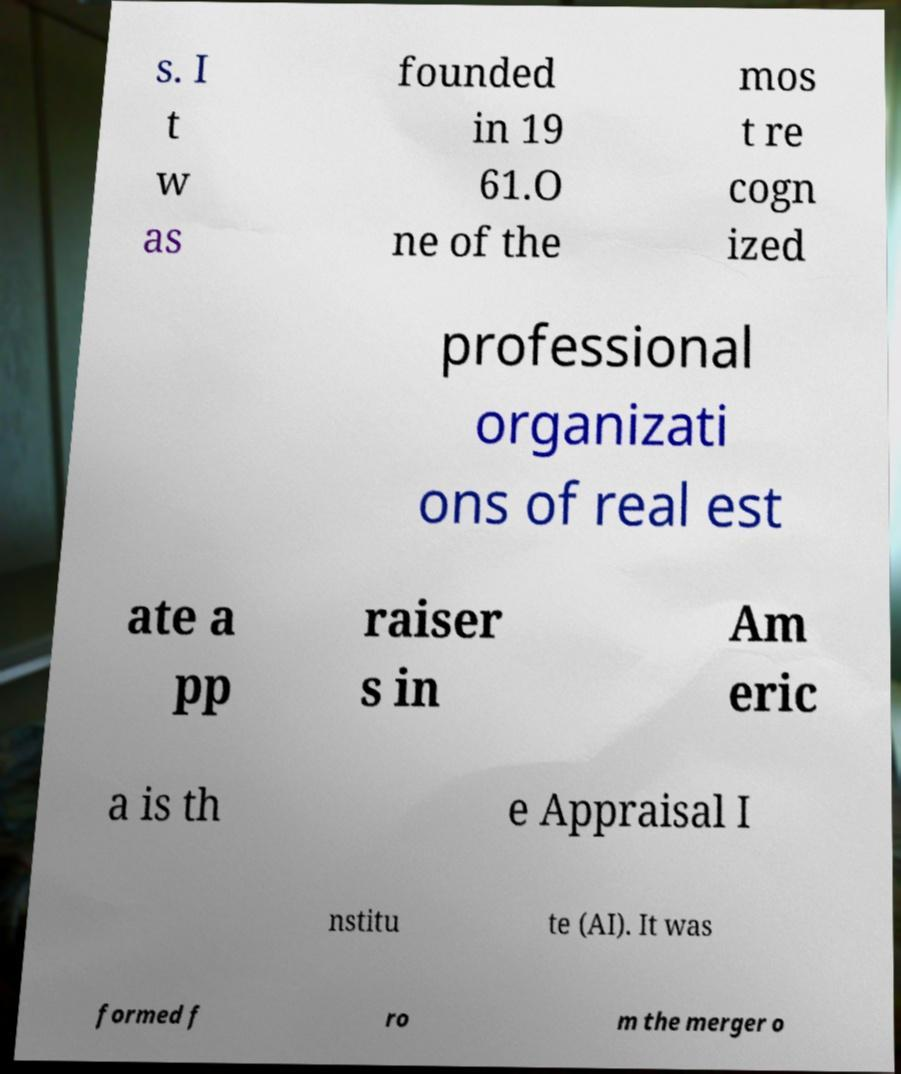Can you read and provide the text displayed in the image?This photo seems to have some interesting text. Can you extract and type it out for me? s. I t w as founded in 19 61.O ne of the mos t re cogn ized professional organizati ons of real est ate a pp raiser s in Am eric a is th e Appraisal I nstitu te (AI). It was formed f ro m the merger o 